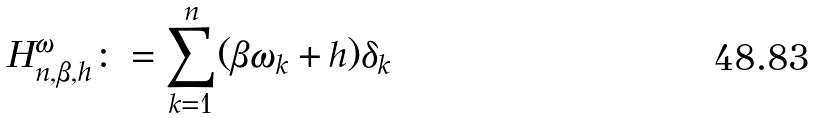<formula> <loc_0><loc_0><loc_500><loc_500>H _ { n , \beta , h } ^ { \omega } \colon = \sum _ { k = 1 } ^ { n } ( \beta \omega _ { k } + h ) \delta _ { k }</formula> 